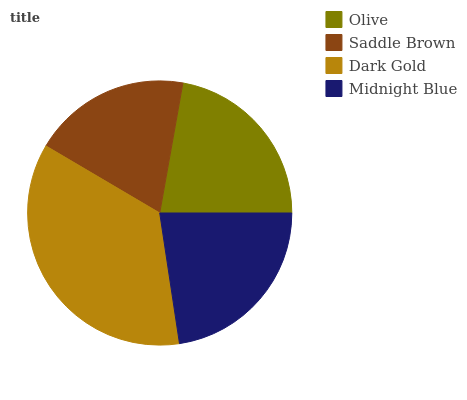Is Saddle Brown the minimum?
Answer yes or no. Yes. Is Dark Gold the maximum?
Answer yes or no. Yes. Is Dark Gold the minimum?
Answer yes or no. No. Is Saddle Brown the maximum?
Answer yes or no. No. Is Dark Gold greater than Saddle Brown?
Answer yes or no. Yes. Is Saddle Brown less than Dark Gold?
Answer yes or no. Yes. Is Saddle Brown greater than Dark Gold?
Answer yes or no. No. Is Dark Gold less than Saddle Brown?
Answer yes or no. No. Is Midnight Blue the high median?
Answer yes or no. Yes. Is Olive the low median?
Answer yes or no. Yes. Is Olive the high median?
Answer yes or no. No. Is Saddle Brown the low median?
Answer yes or no. No. 